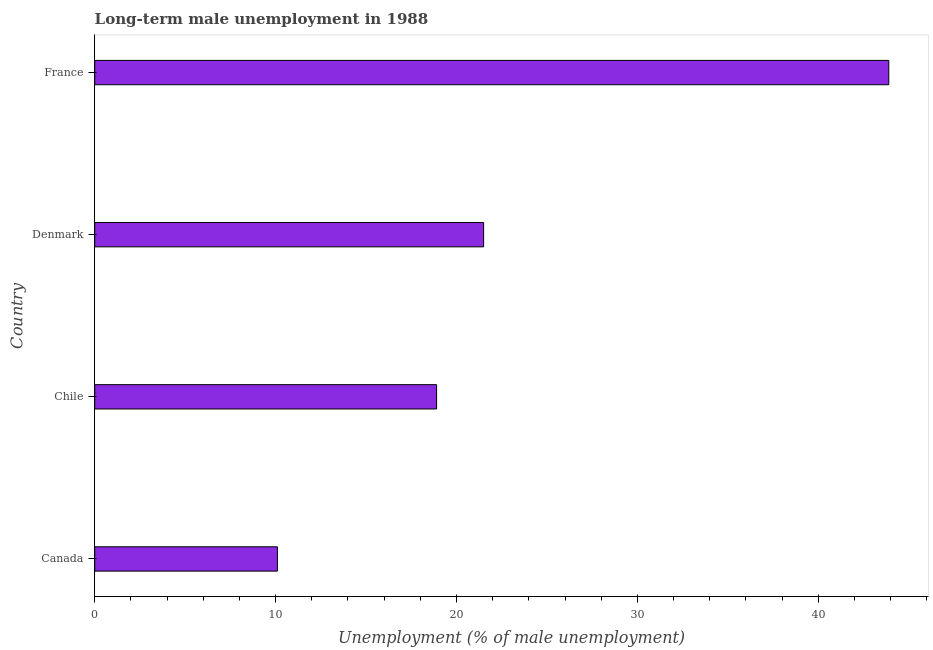Does the graph contain grids?
Provide a short and direct response. No. What is the title of the graph?
Offer a very short reply. Long-term male unemployment in 1988. What is the label or title of the X-axis?
Offer a terse response. Unemployment (% of male unemployment). What is the label or title of the Y-axis?
Provide a short and direct response. Country. What is the long-term male unemployment in Chile?
Make the answer very short. 18.9. Across all countries, what is the maximum long-term male unemployment?
Offer a very short reply. 43.9. Across all countries, what is the minimum long-term male unemployment?
Offer a very short reply. 10.1. What is the sum of the long-term male unemployment?
Keep it short and to the point. 94.4. What is the difference between the long-term male unemployment in Chile and France?
Offer a terse response. -25. What is the average long-term male unemployment per country?
Provide a succinct answer. 23.6. What is the median long-term male unemployment?
Ensure brevity in your answer.  20.2. In how many countries, is the long-term male unemployment greater than 22 %?
Provide a short and direct response. 1. What is the ratio of the long-term male unemployment in Denmark to that in France?
Your answer should be compact. 0.49. Is the long-term male unemployment in Canada less than that in Chile?
Make the answer very short. Yes. What is the difference between the highest and the second highest long-term male unemployment?
Keep it short and to the point. 22.4. Is the sum of the long-term male unemployment in Chile and France greater than the maximum long-term male unemployment across all countries?
Offer a very short reply. Yes. What is the difference between the highest and the lowest long-term male unemployment?
Offer a very short reply. 33.8. Are the values on the major ticks of X-axis written in scientific E-notation?
Your answer should be compact. No. What is the Unemployment (% of male unemployment) in Canada?
Your answer should be very brief. 10.1. What is the Unemployment (% of male unemployment) in Chile?
Your answer should be very brief. 18.9. What is the Unemployment (% of male unemployment) in France?
Your response must be concise. 43.9. What is the difference between the Unemployment (% of male unemployment) in Canada and Chile?
Give a very brief answer. -8.8. What is the difference between the Unemployment (% of male unemployment) in Canada and Denmark?
Your answer should be compact. -11.4. What is the difference between the Unemployment (% of male unemployment) in Canada and France?
Offer a very short reply. -33.8. What is the difference between the Unemployment (% of male unemployment) in Denmark and France?
Offer a terse response. -22.4. What is the ratio of the Unemployment (% of male unemployment) in Canada to that in Chile?
Offer a very short reply. 0.53. What is the ratio of the Unemployment (% of male unemployment) in Canada to that in Denmark?
Ensure brevity in your answer.  0.47. What is the ratio of the Unemployment (% of male unemployment) in Canada to that in France?
Your response must be concise. 0.23. What is the ratio of the Unemployment (% of male unemployment) in Chile to that in Denmark?
Make the answer very short. 0.88. What is the ratio of the Unemployment (% of male unemployment) in Chile to that in France?
Your answer should be compact. 0.43. What is the ratio of the Unemployment (% of male unemployment) in Denmark to that in France?
Give a very brief answer. 0.49. 